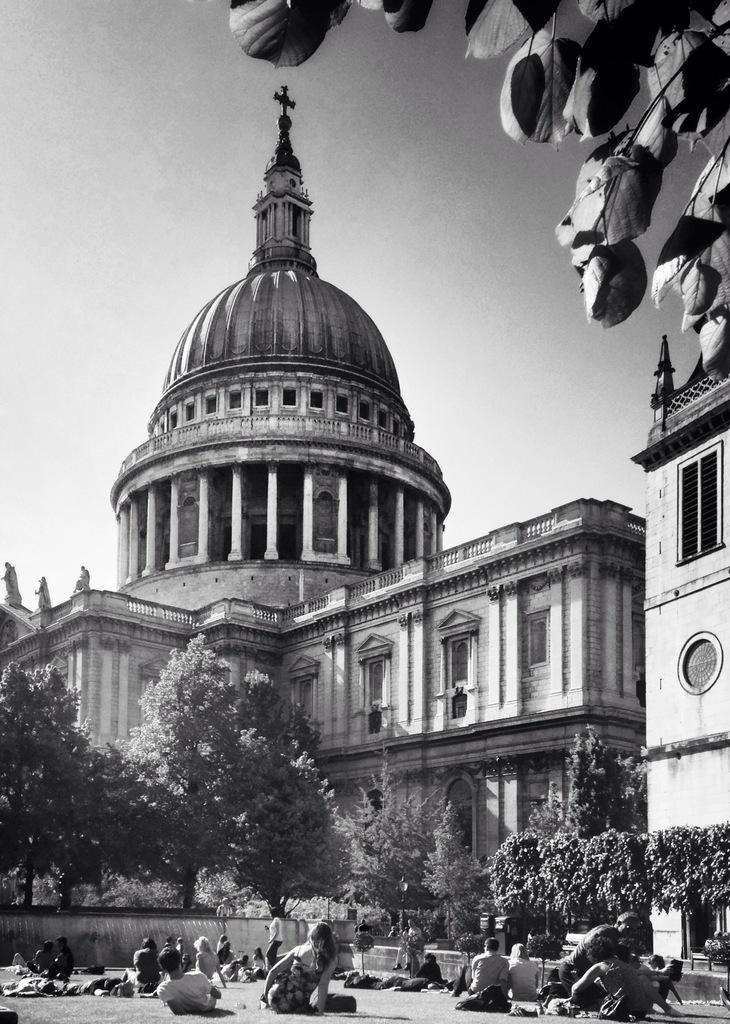Who or what can be seen in the image? There are people in the image. What type of natural elements are present in the image? There are trees in the image. What type of man-made structure is visible in the image? There is a building in the image. What is located at the top of the construction in the image? There is a tomb at the top of the construction in the image. What type of button is being used to control the tomb in the image? There is no button present in the image, and the tomb is not controlled by any button. 